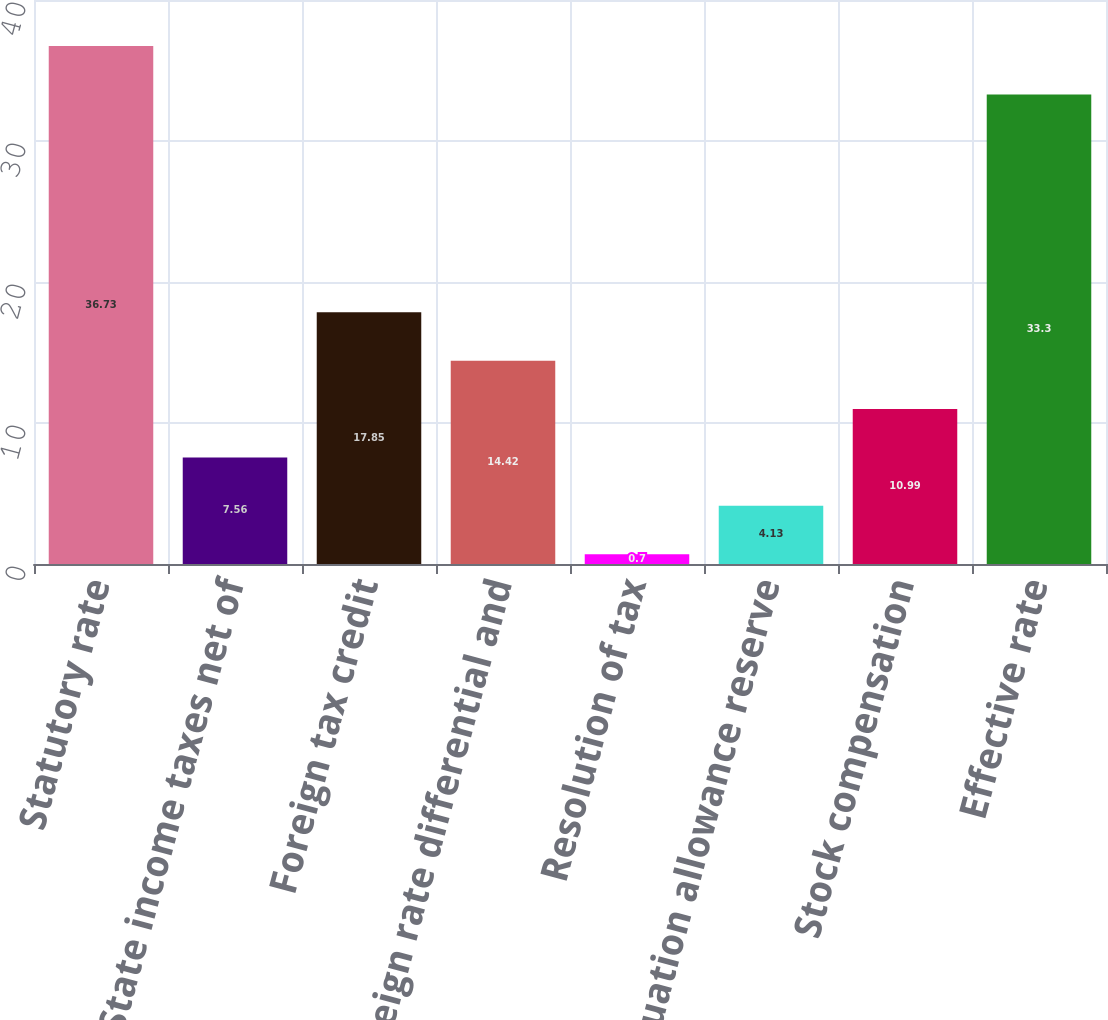Convert chart to OTSL. <chart><loc_0><loc_0><loc_500><loc_500><bar_chart><fcel>Statutory rate<fcel>State income taxes net of<fcel>Foreign tax credit<fcel>Foreign rate differential and<fcel>Resolution of tax<fcel>Valuation allowance reserve<fcel>Stock compensation<fcel>Effective rate<nl><fcel>36.73<fcel>7.56<fcel>17.85<fcel>14.42<fcel>0.7<fcel>4.13<fcel>10.99<fcel>33.3<nl></chart> 